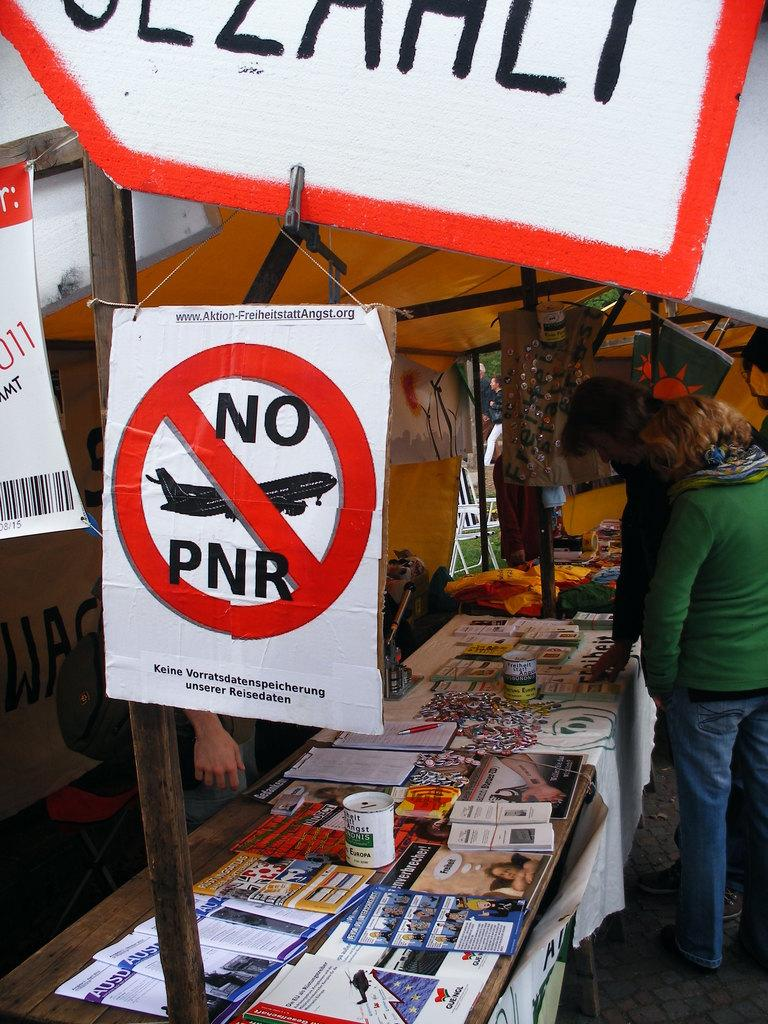Provide a one-sentence caption for the provided image. A roadside stand with the poster that has NO PNR written on it. 